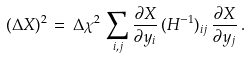Convert formula to latex. <formula><loc_0><loc_0><loc_500><loc_500>( \Delta X ) ^ { 2 } \, = \, \Delta \chi ^ { 2 } \, \sum _ { i , j } \frac { \partial X } { \partial y _ { i } } \, ( H ^ { - 1 } ) _ { i j } \, \frac { \partial X } { \partial y _ { j } } \, .</formula> 